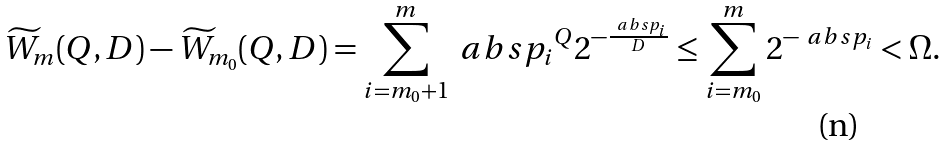Convert formula to latex. <formula><loc_0><loc_0><loc_500><loc_500>\widetilde { W } _ { m } ( Q , D ) - \widetilde { W } _ { m _ { 0 } } ( Q , D ) = \sum _ { i = m _ { 0 } + 1 } ^ { m } \ a b s { p _ { i } } ^ { Q } 2 ^ { - \frac { \ a b s { p _ { i } } } { D } } \leq \sum _ { i = m _ { 0 } } ^ { m } 2 ^ { - \ a b s { p _ { i } } } < \Omega .</formula> 